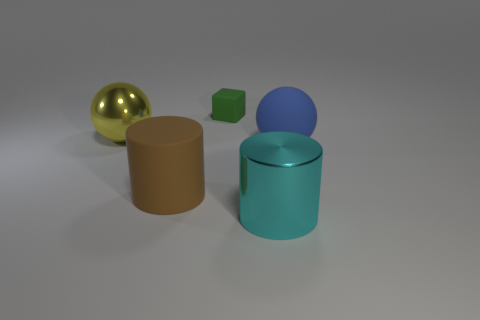Subtract all yellow blocks. Subtract all brown spheres. How many blocks are left? 1 Add 1 cyan rubber cylinders. How many cyan rubber cylinders exist? 1 Add 2 tiny green blocks. How many objects exist? 7 Subtract 0 red cylinders. How many objects are left? 5 Subtract all cylinders. How many objects are left? 3 Subtract 1 cylinders. How many cylinders are left? 1 Subtract all purple cubes. How many purple cylinders are left? 0 Subtract all large brown things. Subtract all rubber cylinders. How many objects are left? 3 Add 5 big brown matte cylinders. How many big brown matte cylinders are left? 6 